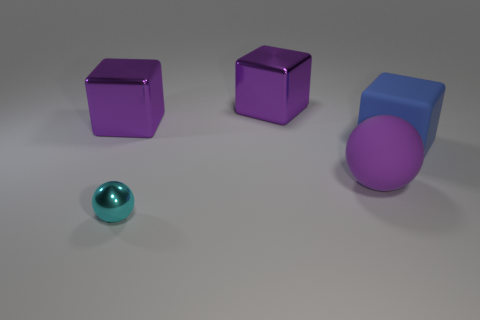Is the color of the small object the same as the large ball?
Make the answer very short. No. How many big cubes are the same material as the cyan object?
Offer a very short reply. 2. There is a sphere that is in front of the big rubber sphere; what material is it?
Your response must be concise. Metal. There is a thing to the right of the purple object that is in front of the thing that is on the right side of the large purple rubber thing; what shape is it?
Your answer should be compact. Cube. There is a rubber object in front of the blue cube; is its color the same as the big metallic cube that is on the right side of the tiny cyan metal thing?
Offer a terse response. Yes. Are there fewer objects that are left of the small ball than blocks behind the big rubber cube?
Provide a succinct answer. Yes. Is there anything else that has the same shape as the big purple rubber object?
Your response must be concise. Yes. What color is the other object that is the same shape as the tiny cyan metal object?
Your answer should be very brief. Purple. There is a big purple rubber thing; is it the same shape as the metal object that is in front of the blue object?
Make the answer very short. Yes. How many things are shiny blocks that are to the right of the tiny cyan ball or things behind the large rubber ball?
Make the answer very short. 3. 